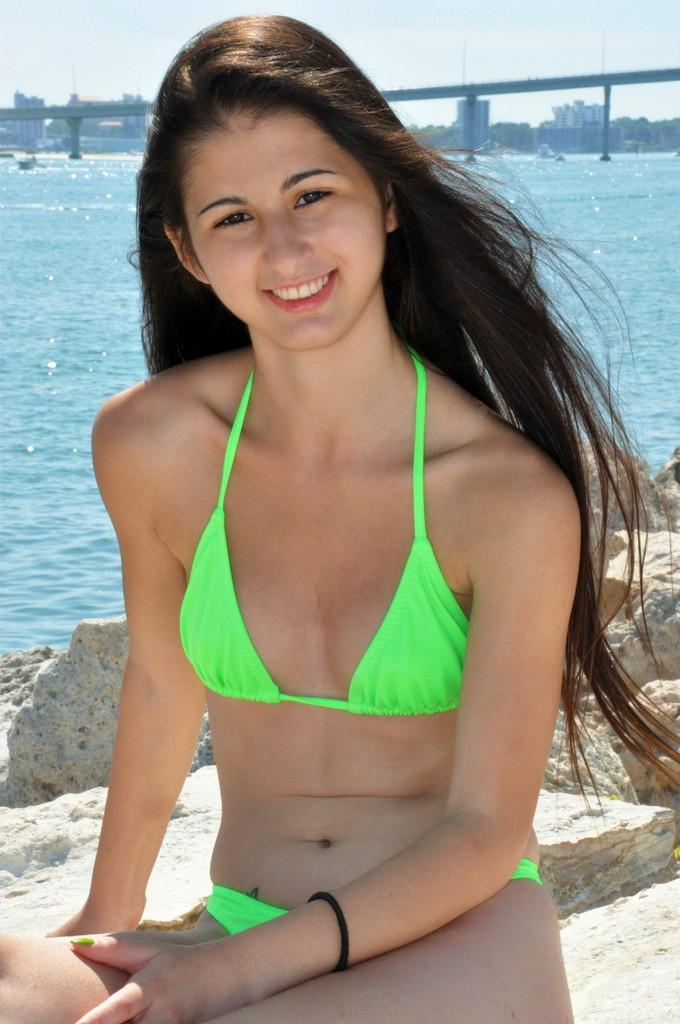Who is in the image? There is a woman in the image. What is the woman doing? The woman is smiling. What can be seen in the background of the image? Water, rocks, a bridge, buildings, and the sky are visible in the background. What type of plate is the woman holding in the image? There is no plate present in the image; the woman is simply smiling. 